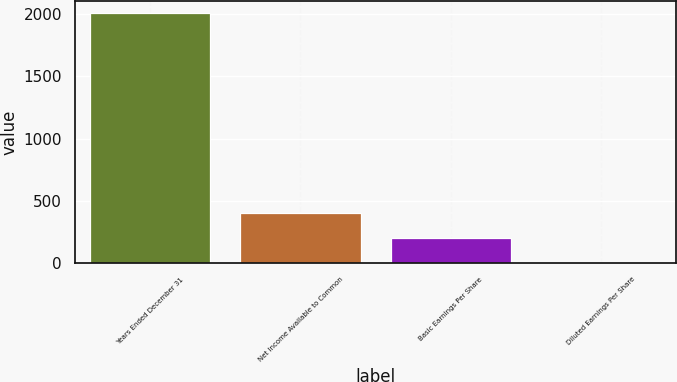Convert chart. <chart><loc_0><loc_0><loc_500><loc_500><bar_chart><fcel>Years Ended December 31<fcel>Net Income Available to Common<fcel>Basic Earnings Per Share<fcel>Diluted Earnings Per Share<nl><fcel>2008<fcel>402.56<fcel>201.88<fcel>1.2<nl></chart> 